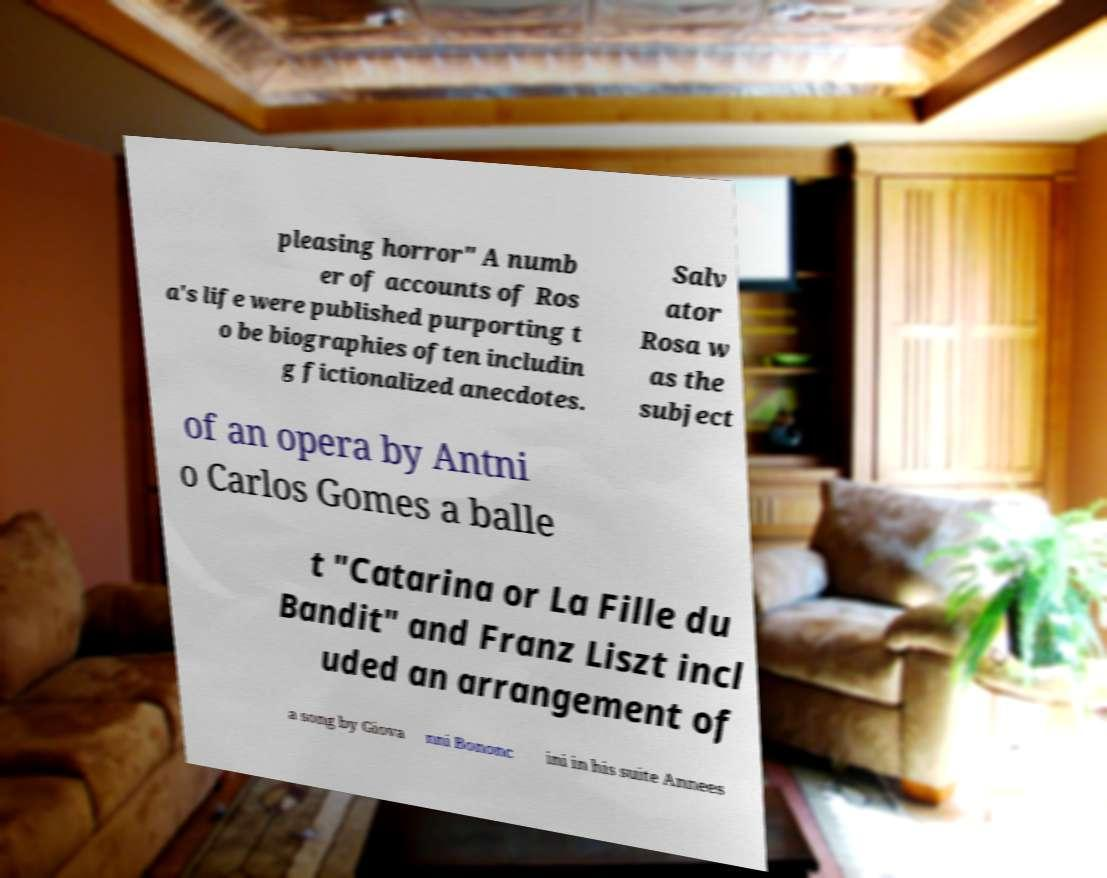What messages or text are displayed in this image? I need them in a readable, typed format. pleasing horror" A numb er of accounts of Ros a's life were published purporting t o be biographies often includin g fictionalized anecdotes. Salv ator Rosa w as the subject of an opera by Antni o Carlos Gomes a balle t "Catarina or La Fille du Bandit" and Franz Liszt incl uded an arrangement of a song by Giova nni Bononc ini in his suite Annees 